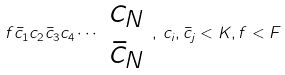Convert formula to latex. <formula><loc_0><loc_0><loc_500><loc_500>f \bar { c } _ { 1 } c _ { 2 } \bar { c } _ { 3 } c _ { 4 } \cdots \begin{array} { c } c _ { N } \\ \bar { c } _ { N } \end{array} , \, c _ { i } , \bar { c } _ { j } < K , f < F</formula> 